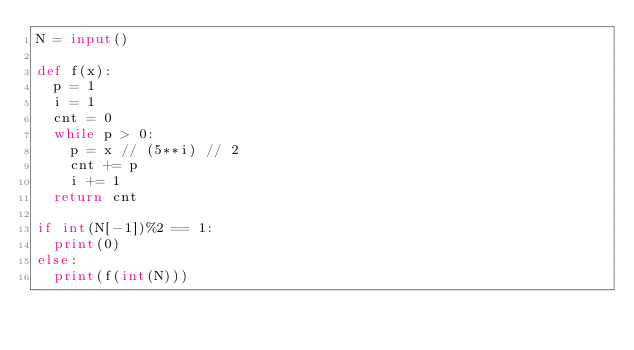Convert code to text. <code><loc_0><loc_0><loc_500><loc_500><_Python_>N = input()

def f(x):
  p = 1
  i = 1
  cnt = 0
  while p > 0:
    p = x // (5**i) // 2
    cnt += p
    i += 1
  return cnt

if int(N[-1])%2 == 1:
  print(0)
else:
  print(f(int(N)))</code> 